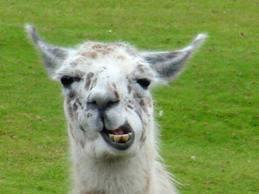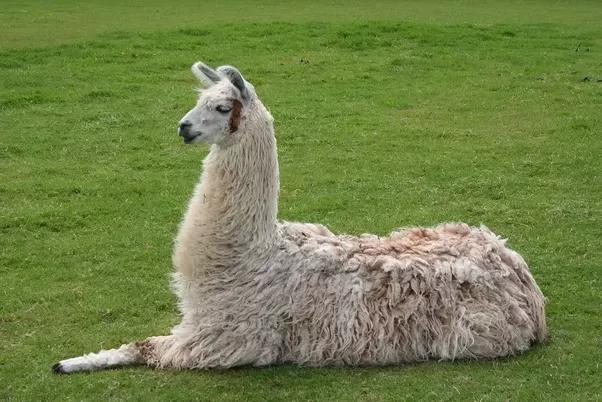The first image is the image on the left, the second image is the image on the right. Examine the images to the left and right. Is the description "There is one human near at least one llama one oft he images." accurate? Answer yes or no. No. The first image is the image on the left, the second image is the image on the right. Evaluate the accuracy of this statement regarding the images: "There is a human interacting with the livestock.". Is it true? Answer yes or no. No. 